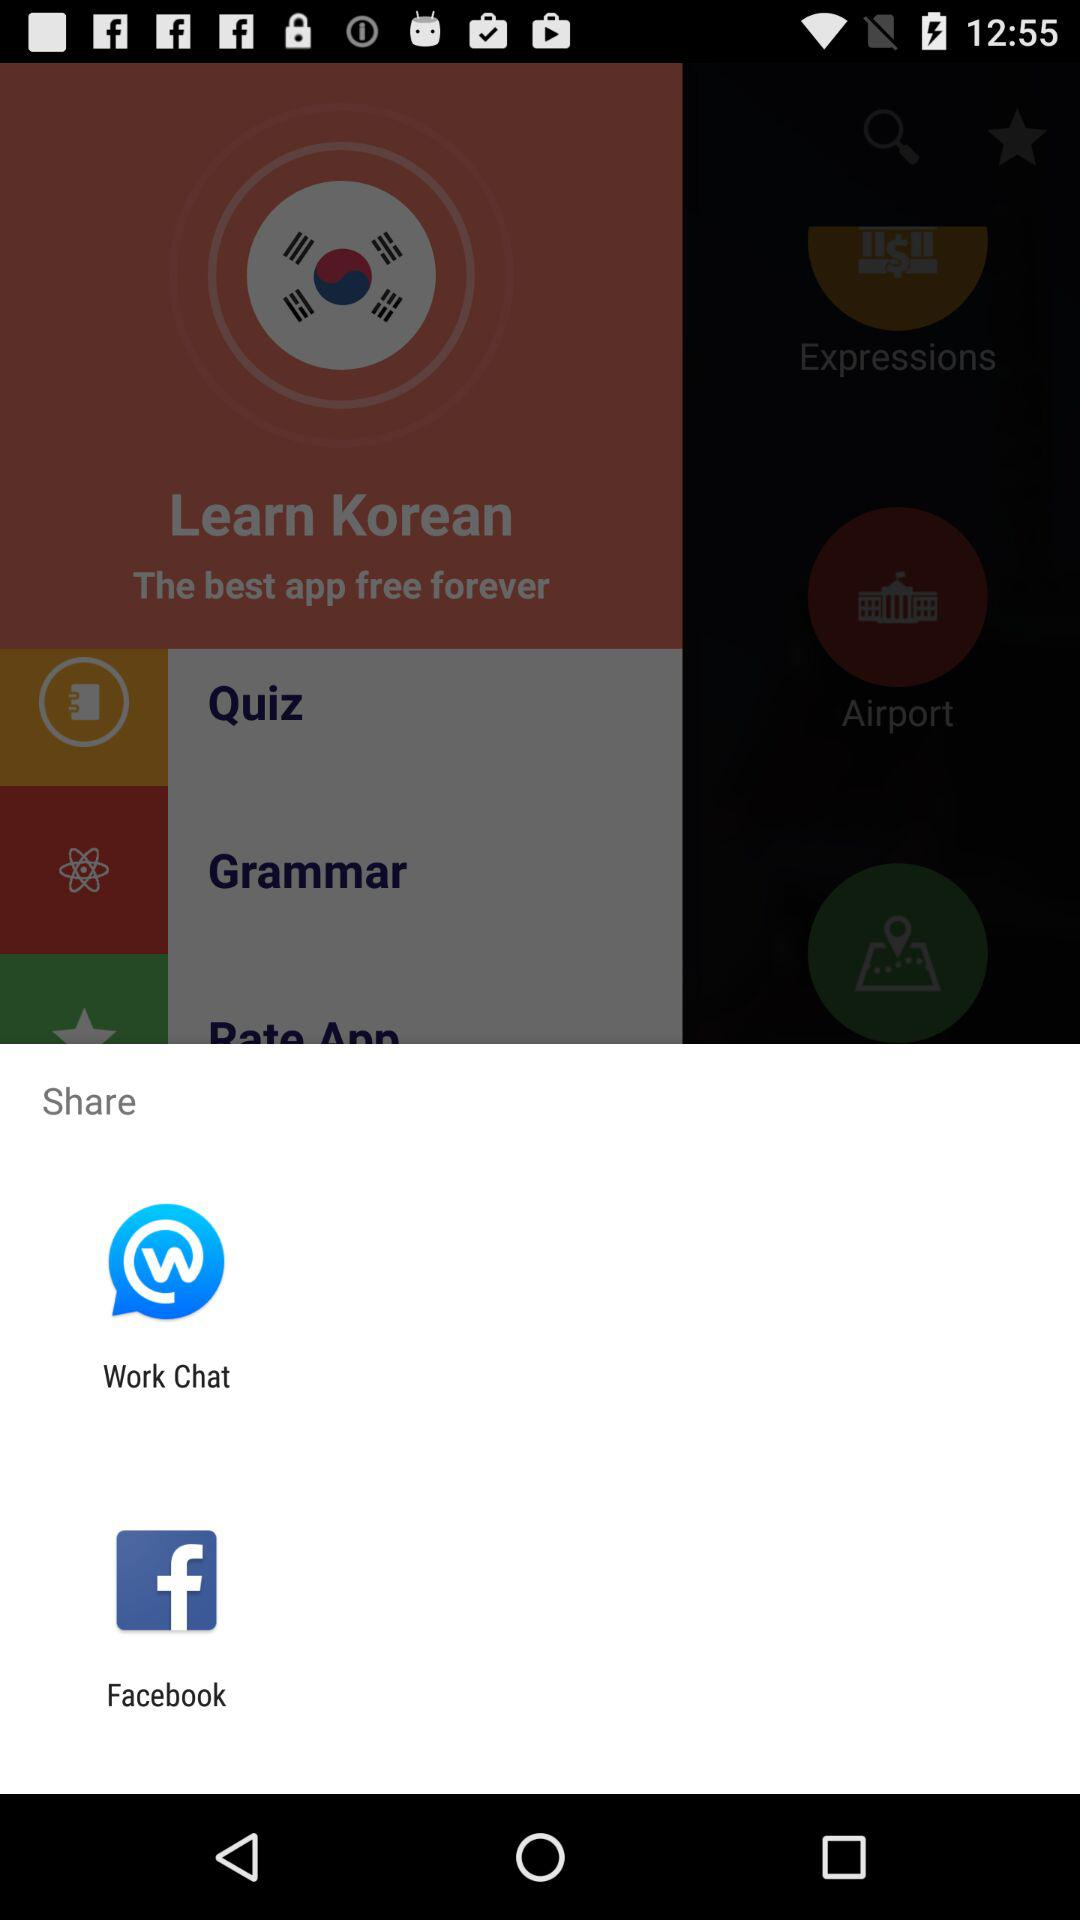What applications are used to share? The applications are "Work Chat" and "Facebook". 